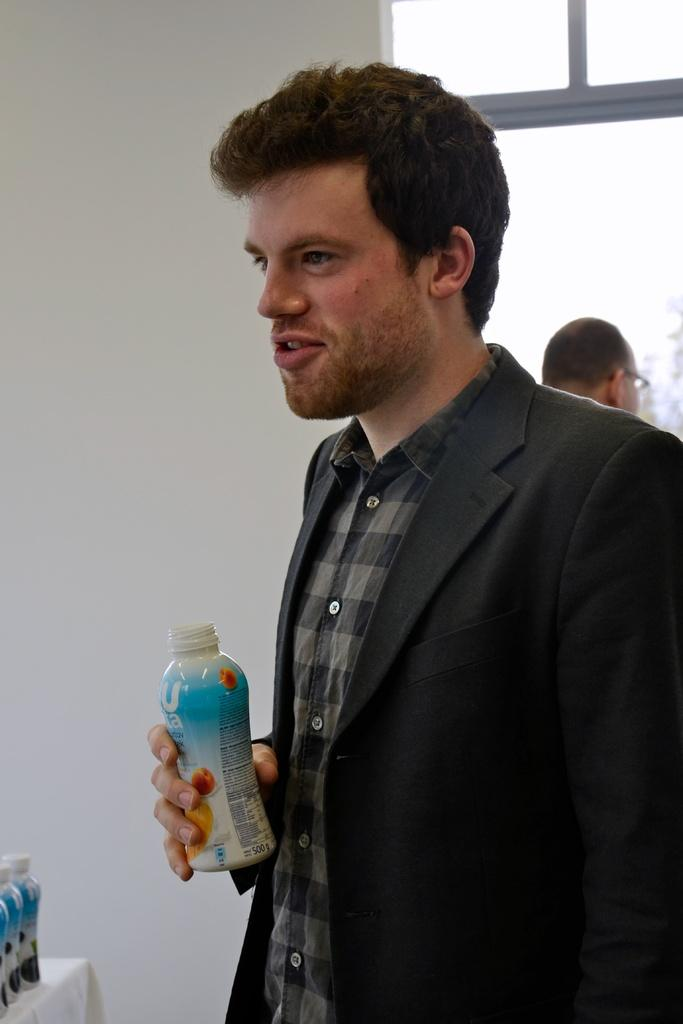What is the man in the image holding? The man is holding a bottle. Can you describe the setting of the image? There is a window in the image, which suggests it might be an indoor scene. Who else is present in the image? There is a person behind the man. What type of joke is the man telling in the image? There is no indication in the image that the man is telling a joke, so it cannot be determined from the picture. 